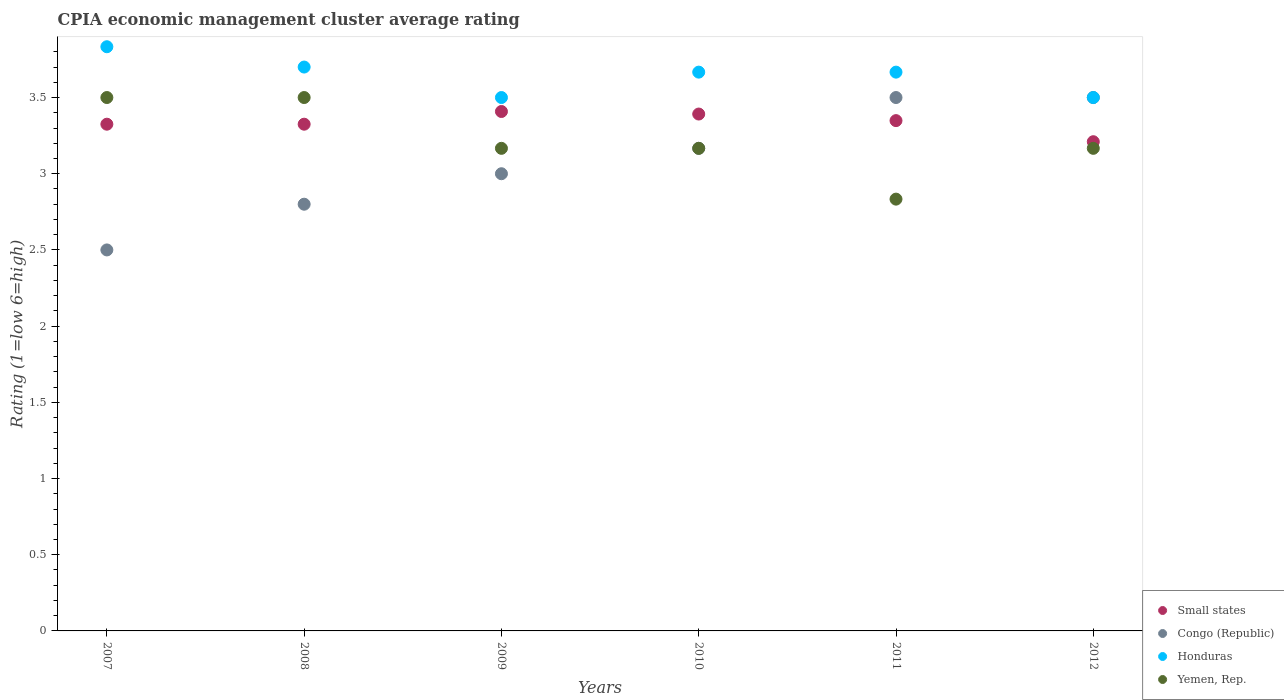How many different coloured dotlines are there?
Provide a short and direct response. 4. What is the CPIA rating in Honduras in 2012?
Your answer should be very brief. 3.5. Across all years, what is the maximum CPIA rating in Honduras?
Offer a terse response. 3.83. Across all years, what is the minimum CPIA rating in Congo (Republic)?
Make the answer very short. 2.5. In which year was the CPIA rating in Small states minimum?
Offer a very short reply. 2012. What is the total CPIA rating in Small states in the graph?
Provide a succinct answer. 20.01. What is the difference between the CPIA rating in Honduras in 2011 and that in 2012?
Keep it short and to the point. 0.17. What is the difference between the CPIA rating in Congo (Republic) in 2009 and the CPIA rating in Honduras in 2007?
Offer a very short reply. -0.83. What is the average CPIA rating in Congo (Republic) per year?
Keep it short and to the point. 3.08. In the year 2008, what is the difference between the CPIA rating in Small states and CPIA rating in Honduras?
Provide a succinct answer. -0.38. In how many years, is the CPIA rating in Congo (Republic) greater than 1.8?
Your response must be concise. 6. What is the ratio of the CPIA rating in Small states in 2007 to that in 2011?
Your answer should be very brief. 0.99. Is the CPIA rating in Small states in 2007 less than that in 2009?
Ensure brevity in your answer.  Yes. Is the difference between the CPIA rating in Small states in 2008 and 2010 greater than the difference between the CPIA rating in Honduras in 2008 and 2010?
Provide a short and direct response. No. What is the difference between the highest and the second highest CPIA rating in Small states?
Your answer should be very brief. 0.02. What is the difference between the highest and the lowest CPIA rating in Yemen, Rep.?
Offer a very short reply. 0.67. Is the sum of the CPIA rating in Honduras in 2007 and 2009 greater than the maximum CPIA rating in Yemen, Rep. across all years?
Offer a very short reply. Yes. Does the CPIA rating in Honduras monotonically increase over the years?
Your response must be concise. No. How many dotlines are there?
Provide a succinct answer. 4. Does the graph contain grids?
Your answer should be very brief. No. Where does the legend appear in the graph?
Keep it short and to the point. Bottom right. What is the title of the graph?
Make the answer very short. CPIA economic management cluster average rating. What is the label or title of the Y-axis?
Your answer should be compact. Rating (1=low 6=high). What is the Rating (1=low 6=high) of Small states in 2007?
Give a very brief answer. 3.33. What is the Rating (1=low 6=high) of Congo (Republic) in 2007?
Your answer should be compact. 2.5. What is the Rating (1=low 6=high) in Honduras in 2007?
Offer a very short reply. 3.83. What is the Rating (1=low 6=high) in Small states in 2008?
Provide a short and direct response. 3.33. What is the Rating (1=low 6=high) of Congo (Republic) in 2008?
Your response must be concise. 2.8. What is the Rating (1=low 6=high) of Small states in 2009?
Provide a succinct answer. 3.41. What is the Rating (1=low 6=high) of Yemen, Rep. in 2009?
Provide a succinct answer. 3.17. What is the Rating (1=low 6=high) in Small states in 2010?
Your answer should be very brief. 3.39. What is the Rating (1=low 6=high) of Congo (Republic) in 2010?
Give a very brief answer. 3.17. What is the Rating (1=low 6=high) of Honduras in 2010?
Ensure brevity in your answer.  3.67. What is the Rating (1=low 6=high) of Yemen, Rep. in 2010?
Offer a very short reply. 3.17. What is the Rating (1=low 6=high) of Small states in 2011?
Your answer should be compact. 3.35. What is the Rating (1=low 6=high) in Honduras in 2011?
Your answer should be compact. 3.67. What is the Rating (1=low 6=high) of Yemen, Rep. in 2011?
Your answer should be compact. 2.83. What is the Rating (1=low 6=high) in Small states in 2012?
Make the answer very short. 3.21. What is the Rating (1=low 6=high) in Congo (Republic) in 2012?
Your answer should be very brief. 3.5. What is the Rating (1=low 6=high) of Yemen, Rep. in 2012?
Offer a terse response. 3.17. Across all years, what is the maximum Rating (1=low 6=high) in Small states?
Your answer should be very brief. 3.41. Across all years, what is the maximum Rating (1=low 6=high) of Honduras?
Offer a very short reply. 3.83. Across all years, what is the minimum Rating (1=low 6=high) of Small states?
Give a very brief answer. 3.21. Across all years, what is the minimum Rating (1=low 6=high) in Honduras?
Your answer should be very brief. 3.5. Across all years, what is the minimum Rating (1=low 6=high) in Yemen, Rep.?
Provide a short and direct response. 2.83. What is the total Rating (1=low 6=high) of Small states in the graph?
Keep it short and to the point. 20.01. What is the total Rating (1=low 6=high) of Congo (Republic) in the graph?
Ensure brevity in your answer.  18.47. What is the total Rating (1=low 6=high) in Honduras in the graph?
Your answer should be compact. 21.87. What is the total Rating (1=low 6=high) of Yemen, Rep. in the graph?
Give a very brief answer. 19.33. What is the difference between the Rating (1=low 6=high) in Small states in 2007 and that in 2008?
Your response must be concise. 0. What is the difference between the Rating (1=low 6=high) in Congo (Republic) in 2007 and that in 2008?
Keep it short and to the point. -0.3. What is the difference between the Rating (1=low 6=high) of Honduras in 2007 and that in 2008?
Provide a short and direct response. 0.13. What is the difference between the Rating (1=low 6=high) of Small states in 2007 and that in 2009?
Your answer should be compact. -0.08. What is the difference between the Rating (1=low 6=high) of Congo (Republic) in 2007 and that in 2009?
Your answer should be compact. -0.5. What is the difference between the Rating (1=low 6=high) of Small states in 2007 and that in 2010?
Provide a short and direct response. -0.07. What is the difference between the Rating (1=low 6=high) of Congo (Republic) in 2007 and that in 2010?
Keep it short and to the point. -0.67. What is the difference between the Rating (1=low 6=high) of Small states in 2007 and that in 2011?
Provide a short and direct response. -0.02. What is the difference between the Rating (1=low 6=high) in Congo (Republic) in 2007 and that in 2011?
Offer a very short reply. -1. What is the difference between the Rating (1=low 6=high) of Honduras in 2007 and that in 2011?
Keep it short and to the point. 0.17. What is the difference between the Rating (1=low 6=high) in Small states in 2007 and that in 2012?
Your response must be concise. 0.11. What is the difference between the Rating (1=low 6=high) of Congo (Republic) in 2007 and that in 2012?
Make the answer very short. -1. What is the difference between the Rating (1=low 6=high) of Honduras in 2007 and that in 2012?
Offer a terse response. 0.33. What is the difference between the Rating (1=low 6=high) of Small states in 2008 and that in 2009?
Ensure brevity in your answer.  -0.08. What is the difference between the Rating (1=low 6=high) of Small states in 2008 and that in 2010?
Keep it short and to the point. -0.07. What is the difference between the Rating (1=low 6=high) in Congo (Republic) in 2008 and that in 2010?
Offer a terse response. -0.37. What is the difference between the Rating (1=low 6=high) in Honduras in 2008 and that in 2010?
Your response must be concise. 0.03. What is the difference between the Rating (1=low 6=high) in Small states in 2008 and that in 2011?
Ensure brevity in your answer.  -0.02. What is the difference between the Rating (1=low 6=high) in Congo (Republic) in 2008 and that in 2011?
Ensure brevity in your answer.  -0.7. What is the difference between the Rating (1=low 6=high) of Honduras in 2008 and that in 2011?
Your response must be concise. 0.03. What is the difference between the Rating (1=low 6=high) in Yemen, Rep. in 2008 and that in 2011?
Give a very brief answer. 0.67. What is the difference between the Rating (1=low 6=high) in Small states in 2008 and that in 2012?
Make the answer very short. 0.11. What is the difference between the Rating (1=low 6=high) in Congo (Republic) in 2008 and that in 2012?
Keep it short and to the point. -0.7. What is the difference between the Rating (1=low 6=high) in Yemen, Rep. in 2008 and that in 2012?
Keep it short and to the point. 0.33. What is the difference between the Rating (1=low 6=high) in Small states in 2009 and that in 2010?
Provide a succinct answer. 0.02. What is the difference between the Rating (1=low 6=high) in Congo (Republic) in 2009 and that in 2010?
Your answer should be compact. -0.17. What is the difference between the Rating (1=low 6=high) in Yemen, Rep. in 2009 and that in 2010?
Offer a very short reply. 0. What is the difference between the Rating (1=low 6=high) in Small states in 2009 and that in 2011?
Make the answer very short. 0.06. What is the difference between the Rating (1=low 6=high) in Small states in 2009 and that in 2012?
Offer a very short reply. 0.2. What is the difference between the Rating (1=low 6=high) in Congo (Republic) in 2009 and that in 2012?
Provide a succinct answer. -0.5. What is the difference between the Rating (1=low 6=high) in Yemen, Rep. in 2009 and that in 2012?
Provide a short and direct response. 0. What is the difference between the Rating (1=low 6=high) of Small states in 2010 and that in 2011?
Provide a short and direct response. 0.04. What is the difference between the Rating (1=low 6=high) of Congo (Republic) in 2010 and that in 2011?
Keep it short and to the point. -0.33. What is the difference between the Rating (1=low 6=high) in Honduras in 2010 and that in 2011?
Ensure brevity in your answer.  0. What is the difference between the Rating (1=low 6=high) of Yemen, Rep. in 2010 and that in 2011?
Keep it short and to the point. 0.33. What is the difference between the Rating (1=low 6=high) in Small states in 2010 and that in 2012?
Offer a terse response. 0.18. What is the difference between the Rating (1=low 6=high) of Congo (Republic) in 2010 and that in 2012?
Ensure brevity in your answer.  -0.33. What is the difference between the Rating (1=low 6=high) in Small states in 2011 and that in 2012?
Offer a very short reply. 0.14. What is the difference between the Rating (1=low 6=high) in Honduras in 2011 and that in 2012?
Give a very brief answer. 0.17. What is the difference between the Rating (1=low 6=high) of Yemen, Rep. in 2011 and that in 2012?
Your answer should be very brief. -0.33. What is the difference between the Rating (1=low 6=high) of Small states in 2007 and the Rating (1=low 6=high) of Congo (Republic) in 2008?
Provide a succinct answer. 0.53. What is the difference between the Rating (1=low 6=high) in Small states in 2007 and the Rating (1=low 6=high) in Honduras in 2008?
Keep it short and to the point. -0.38. What is the difference between the Rating (1=low 6=high) of Small states in 2007 and the Rating (1=low 6=high) of Yemen, Rep. in 2008?
Keep it short and to the point. -0.17. What is the difference between the Rating (1=low 6=high) of Congo (Republic) in 2007 and the Rating (1=low 6=high) of Honduras in 2008?
Your response must be concise. -1.2. What is the difference between the Rating (1=low 6=high) in Congo (Republic) in 2007 and the Rating (1=low 6=high) in Yemen, Rep. in 2008?
Your answer should be very brief. -1. What is the difference between the Rating (1=low 6=high) in Honduras in 2007 and the Rating (1=low 6=high) in Yemen, Rep. in 2008?
Provide a short and direct response. 0.33. What is the difference between the Rating (1=low 6=high) in Small states in 2007 and the Rating (1=low 6=high) in Congo (Republic) in 2009?
Make the answer very short. 0.33. What is the difference between the Rating (1=low 6=high) in Small states in 2007 and the Rating (1=low 6=high) in Honduras in 2009?
Provide a succinct answer. -0.17. What is the difference between the Rating (1=low 6=high) in Small states in 2007 and the Rating (1=low 6=high) in Yemen, Rep. in 2009?
Give a very brief answer. 0.16. What is the difference between the Rating (1=low 6=high) of Honduras in 2007 and the Rating (1=low 6=high) of Yemen, Rep. in 2009?
Give a very brief answer. 0.67. What is the difference between the Rating (1=low 6=high) of Small states in 2007 and the Rating (1=low 6=high) of Congo (Republic) in 2010?
Keep it short and to the point. 0.16. What is the difference between the Rating (1=low 6=high) in Small states in 2007 and the Rating (1=low 6=high) in Honduras in 2010?
Your answer should be compact. -0.34. What is the difference between the Rating (1=low 6=high) in Small states in 2007 and the Rating (1=low 6=high) in Yemen, Rep. in 2010?
Ensure brevity in your answer.  0.16. What is the difference between the Rating (1=low 6=high) in Congo (Republic) in 2007 and the Rating (1=low 6=high) in Honduras in 2010?
Provide a short and direct response. -1.17. What is the difference between the Rating (1=low 6=high) of Honduras in 2007 and the Rating (1=low 6=high) of Yemen, Rep. in 2010?
Keep it short and to the point. 0.67. What is the difference between the Rating (1=low 6=high) of Small states in 2007 and the Rating (1=low 6=high) of Congo (Republic) in 2011?
Provide a succinct answer. -0.17. What is the difference between the Rating (1=low 6=high) in Small states in 2007 and the Rating (1=low 6=high) in Honduras in 2011?
Your response must be concise. -0.34. What is the difference between the Rating (1=low 6=high) in Small states in 2007 and the Rating (1=low 6=high) in Yemen, Rep. in 2011?
Your answer should be very brief. 0.49. What is the difference between the Rating (1=low 6=high) of Congo (Republic) in 2007 and the Rating (1=low 6=high) of Honduras in 2011?
Your response must be concise. -1.17. What is the difference between the Rating (1=low 6=high) in Congo (Republic) in 2007 and the Rating (1=low 6=high) in Yemen, Rep. in 2011?
Ensure brevity in your answer.  -0.33. What is the difference between the Rating (1=low 6=high) in Small states in 2007 and the Rating (1=low 6=high) in Congo (Republic) in 2012?
Make the answer very short. -0.17. What is the difference between the Rating (1=low 6=high) in Small states in 2007 and the Rating (1=low 6=high) in Honduras in 2012?
Your answer should be very brief. -0.17. What is the difference between the Rating (1=low 6=high) in Small states in 2007 and the Rating (1=low 6=high) in Yemen, Rep. in 2012?
Keep it short and to the point. 0.16. What is the difference between the Rating (1=low 6=high) of Congo (Republic) in 2007 and the Rating (1=low 6=high) of Yemen, Rep. in 2012?
Your response must be concise. -0.67. What is the difference between the Rating (1=low 6=high) of Small states in 2008 and the Rating (1=low 6=high) of Congo (Republic) in 2009?
Your response must be concise. 0.33. What is the difference between the Rating (1=low 6=high) in Small states in 2008 and the Rating (1=low 6=high) in Honduras in 2009?
Provide a succinct answer. -0.17. What is the difference between the Rating (1=low 6=high) of Small states in 2008 and the Rating (1=low 6=high) of Yemen, Rep. in 2009?
Offer a terse response. 0.16. What is the difference between the Rating (1=low 6=high) of Congo (Republic) in 2008 and the Rating (1=low 6=high) of Yemen, Rep. in 2009?
Offer a very short reply. -0.37. What is the difference between the Rating (1=low 6=high) in Honduras in 2008 and the Rating (1=low 6=high) in Yemen, Rep. in 2009?
Give a very brief answer. 0.53. What is the difference between the Rating (1=low 6=high) of Small states in 2008 and the Rating (1=low 6=high) of Congo (Republic) in 2010?
Give a very brief answer. 0.16. What is the difference between the Rating (1=low 6=high) in Small states in 2008 and the Rating (1=low 6=high) in Honduras in 2010?
Provide a succinct answer. -0.34. What is the difference between the Rating (1=low 6=high) of Small states in 2008 and the Rating (1=low 6=high) of Yemen, Rep. in 2010?
Offer a very short reply. 0.16. What is the difference between the Rating (1=low 6=high) in Congo (Republic) in 2008 and the Rating (1=low 6=high) in Honduras in 2010?
Give a very brief answer. -0.87. What is the difference between the Rating (1=low 6=high) of Congo (Republic) in 2008 and the Rating (1=low 6=high) of Yemen, Rep. in 2010?
Keep it short and to the point. -0.37. What is the difference between the Rating (1=low 6=high) in Honduras in 2008 and the Rating (1=low 6=high) in Yemen, Rep. in 2010?
Keep it short and to the point. 0.53. What is the difference between the Rating (1=low 6=high) of Small states in 2008 and the Rating (1=low 6=high) of Congo (Republic) in 2011?
Provide a succinct answer. -0.17. What is the difference between the Rating (1=low 6=high) in Small states in 2008 and the Rating (1=low 6=high) in Honduras in 2011?
Your response must be concise. -0.34. What is the difference between the Rating (1=low 6=high) of Small states in 2008 and the Rating (1=low 6=high) of Yemen, Rep. in 2011?
Offer a very short reply. 0.49. What is the difference between the Rating (1=low 6=high) in Congo (Republic) in 2008 and the Rating (1=low 6=high) in Honduras in 2011?
Offer a terse response. -0.87. What is the difference between the Rating (1=low 6=high) in Congo (Republic) in 2008 and the Rating (1=low 6=high) in Yemen, Rep. in 2011?
Give a very brief answer. -0.03. What is the difference between the Rating (1=low 6=high) of Honduras in 2008 and the Rating (1=low 6=high) of Yemen, Rep. in 2011?
Provide a short and direct response. 0.87. What is the difference between the Rating (1=low 6=high) of Small states in 2008 and the Rating (1=low 6=high) of Congo (Republic) in 2012?
Ensure brevity in your answer.  -0.17. What is the difference between the Rating (1=low 6=high) in Small states in 2008 and the Rating (1=low 6=high) in Honduras in 2012?
Ensure brevity in your answer.  -0.17. What is the difference between the Rating (1=low 6=high) in Small states in 2008 and the Rating (1=low 6=high) in Yemen, Rep. in 2012?
Give a very brief answer. 0.16. What is the difference between the Rating (1=low 6=high) of Congo (Republic) in 2008 and the Rating (1=low 6=high) of Yemen, Rep. in 2012?
Ensure brevity in your answer.  -0.37. What is the difference between the Rating (1=low 6=high) of Honduras in 2008 and the Rating (1=low 6=high) of Yemen, Rep. in 2012?
Your answer should be very brief. 0.53. What is the difference between the Rating (1=low 6=high) of Small states in 2009 and the Rating (1=low 6=high) of Congo (Republic) in 2010?
Your response must be concise. 0.24. What is the difference between the Rating (1=low 6=high) of Small states in 2009 and the Rating (1=low 6=high) of Honduras in 2010?
Provide a short and direct response. -0.26. What is the difference between the Rating (1=low 6=high) in Small states in 2009 and the Rating (1=low 6=high) in Yemen, Rep. in 2010?
Your answer should be compact. 0.24. What is the difference between the Rating (1=low 6=high) of Congo (Republic) in 2009 and the Rating (1=low 6=high) of Yemen, Rep. in 2010?
Your response must be concise. -0.17. What is the difference between the Rating (1=low 6=high) in Small states in 2009 and the Rating (1=low 6=high) in Congo (Republic) in 2011?
Ensure brevity in your answer.  -0.09. What is the difference between the Rating (1=low 6=high) of Small states in 2009 and the Rating (1=low 6=high) of Honduras in 2011?
Make the answer very short. -0.26. What is the difference between the Rating (1=low 6=high) of Small states in 2009 and the Rating (1=low 6=high) of Yemen, Rep. in 2011?
Provide a succinct answer. 0.57. What is the difference between the Rating (1=low 6=high) in Small states in 2009 and the Rating (1=low 6=high) in Congo (Republic) in 2012?
Provide a short and direct response. -0.09. What is the difference between the Rating (1=low 6=high) of Small states in 2009 and the Rating (1=low 6=high) of Honduras in 2012?
Provide a succinct answer. -0.09. What is the difference between the Rating (1=low 6=high) of Small states in 2009 and the Rating (1=low 6=high) of Yemen, Rep. in 2012?
Keep it short and to the point. 0.24. What is the difference between the Rating (1=low 6=high) of Congo (Republic) in 2009 and the Rating (1=low 6=high) of Yemen, Rep. in 2012?
Make the answer very short. -0.17. What is the difference between the Rating (1=low 6=high) of Honduras in 2009 and the Rating (1=low 6=high) of Yemen, Rep. in 2012?
Provide a short and direct response. 0.33. What is the difference between the Rating (1=low 6=high) of Small states in 2010 and the Rating (1=low 6=high) of Congo (Republic) in 2011?
Your response must be concise. -0.11. What is the difference between the Rating (1=low 6=high) in Small states in 2010 and the Rating (1=low 6=high) in Honduras in 2011?
Your response must be concise. -0.28. What is the difference between the Rating (1=low 6=high) of Small states in 2010 and the Rating (1=low 6=high) of Yemen, Rep. in 2011?
Your answer should be very brief. 0.56. What is the difference between the Rating (1=low 6=high) in Congo (Republic) in 2010 and the Rating (1=low 6=high) in Yemen, Rep. in 2011?
Provide a short and direct response. 0.33. What is the difference between the Rating (1=low 6=high) in Honduras in 2010 and the Rating (1=low 6=high) in Yemen, Rep. in 2011?
Make the answer very short. 0.83. What is the difference between the Rating (1=low 6=high) in Small states in 2010 and the Rating (1=low 6=high) in Congo (Republic) in 2012?
Your answer should be compact. -0.11. What is the difference between the Rating (1=low 6=high) of Small states in 2010 and the Rating (1=low 6=high) of Honduras in 2012?
Keep it short and to the point. -0.11. What is the difference between the Rating (1=low 6=high) in Small states in 2010 and the Rating (1=low 6=high) in Yemen, Rep. in 2012?
Your answer should be compact. 0.23. What is the difference between the Rating (1=low 6=high) in Congo (Republic) in 2010 and the Rating (1=low 6=high) in Honduras in 2012?
Give a very brief answer. -0.33. What is the difference between the Rating (1=low 6=high) of Congo (Republic) in 2010 and the Rating (1=low 6=high) of Yemen, Rep. in 2012?
Ensure brevity in your answer.  0. What is the difference between the Rating (1=low 6=high) in Honduras in 2010 and the Rating (1=low 6=high) in Yemen, Rep. in 2012?
Your answer should be compact. 0.5. What is the difference between the Rating (1=low 6=high) of Small states in 2011 and the Rating (1=low 6=high) of Congo (Republic) in 2012?
Ensure brevity in your answer.  -0.15. What is the difference between the Rating (1=low 6=high) of Small states in 2011 and the Rating (1=low 6=high) of Honduras in 2012?
Your answer should be compact. -0.15. What is the difference between the Rating (1=low 6=high) in Small states in 2011 and the Rating (1=low 6=high) in Yemen, Rep. in 2012?
Make the answer very short. 0.18. What is the average Rating (1=low 6=high) of Small states per year?
Offer a very short reply. 3.33. What is the average Rating (1=low 6=high) in Congo (Republic) per year?
Offer a very short reply. 3.08. What is the average Rating (1=low 6=high) in Honduras per year?
Your answer should be compact. 3.64. What is the average Rating (1=low 6=high) in Yemen, Rep. per year?
Offer a very short reply. 3.22. In the year 2007, what is the difference between the Rating (1=low 6=high) of Small states and Rating (1=low 6=high) of Congo (Republic)?
Ensure brevity in your answer.  0.82. In the year 2007, what is the difference between the Rating (1=low 6=high) of Small states and Rating (1=low 6=high) of Honduras?
Offer a terse response. -0.51. In the year 2007, what is the difference between the Rating (1=low 6=high) in Small states and Rating (1=low 6=high) in Yemen, Rep.?
Offer a very short reply. -0.17. In the year 2007, what is the difference between the Rating (1=low 6=high) in Congo (Republic) and Rating (1=low 6=high) in Honduras?
Keep it short and to the point. -1.33. In the year 2007, what is the difference between the Rating (1=low 6=high) in Honduras and Rating (1=low 6=high) in Yemen, Rep.?
Keep it short and to the point. 0.33. In the year 2008, what is the difference between the Rating (1=low 6=high) of Small states and Rating (1=low 6=high) of Congo (Republic)?
Your answer should be compact. 0.53. In the year 2008, what is the difference between the Rating (1=low 6=high) in Small states and Rating (1=low 6=high) in Honduras?
Offer a terse response. -0.38. In the year 2008, what is the difference between the Rating (1=low 6=high) in Small states and Rating (1=low 6=high) in Yemen, Rep.?
Your response must be concise. -0.17. In the year 2008, what is the difference between the Rating (1=low 6=high) of Congo (Republic) and Rating (1=low 6=high) of Yemen, Rep.?
Your answer should be very brief. -0.7. In the year 2009, what is the difference between the Rating (1=low 6=high) of Small states and Rating (1=low 6=high) of Congo (Republic)?
Your response must be concise. 0.41. In the year 2009, what is the difference between the Rating (1=low 6=high) of Small states and Rating (1=low 6=high) of Honduras?
Make the answer very short. -0.09. In the year 2009, what is the difference between the Rating (1=low 6=high) in Small states and Rating (1=low 6=high) in Yemen, Rep.?
Your answer should be very brief. 0.24. In the year 2009, what is the difference between the Rating (1=low 6=high) of Congo (Republic) and Rating (1=low 6=high) of Honduras?
Offer a very short reply. -0.5. In the year 2009, what is the difference between the Rating (1=low 6=high) of Congo (Republic) and Rating (1=low 6=high) of Yemen, Rep.?
Make the answer very short. -0.17. In the year 2010, what is the difference between the Rating (1=low 6=high) in Small states and Rating (1=low 6=high) in Congo (Republic)?
Your response must be concise. 0.23. In the year 2010, what is the difference between the Rating (1=low 6=high) of Small states and Rating (1=low 6=high) of Honduras?
Your answer should be compact. -0.28. In the year 2010, what is the difference between the Rating (1=low 6=high) of Small states and Rating (1=low 6=high) of Yemen, Rep.?
Offer a very short reply. 0.23. In the year 2010, what is the difference between the Rating (1=low 6=high) in Congo (Republic) and Rating (1=low 6=high) in Honduras?
Give a very brief answer. -0.5. In the year 2010, what is the difference between the Rating (1=low 6=high) in Honduras and Rating (1=low 6=high) in Yemen, Rep.?
Your response must be concise. 0.5. In the year 2011, what is the difference between the Rating (1=low 6=high) in Small states and Rating (1=low 6=high) in Congo (Republic)?
Offer a terse response. -0.15. In the year 2011, what is the difference between the Rating (1=low 6=high) of Small states and Rating (1=low 6=high) of Honduras?
Ensure brevity in your answer.  -0.32. In the year 2011, what is the difference between the Rating (1=low 6=high) in Small states and Rating (1=low 6=high) in Yemen, Rep.?
Provide a succinct answer. 0.52. In the year 2011, what is the difference between the Rating (1=low 6=high) in Congo (Republic) and Rating (1=low 6=high) in Yemen, Rep.?
Provide a short and direct response. 0.67. In the year 2011, what is the difference between the Rating (1=low 6=high) of Honduras and Rating (1=low 6=high) of Yemen, Rep.?
Provide a short and direct response. 0.83. In the year 2012, what is the difference between the Rating (1=low 6=high) in Small states and Rating (1=low 6=high) in Congo (Republic)?
Keep it short and to the point. -0.29. In the year 2012, what is the difference between the Rating (1=low 6=high) of Small states and Rating (1=low 6=high) of Honduras?
Offer a very short reply. -0.29. In the year 2012, what is the difference between the Rating (1=low 6=high) of Small states and Rating (1=low 6=high) of Yemen, Rep.?
Ensure brevity in your answer.  0.04. In the year 2012, what is the difference between the Rating (1=low 6=high) of Congo (Republic) and Rating (1=low 6=high) of Honduras?
Your answer should be very brief. 0. In the year 2012, what is the difference between the Rating (1=low 6=high) in Congo (Republic) and Rating (1=low 6=high) in Yemen, Rep.?
Ensure brevity in your answer.  0.33. What is the ratio of the Rating (1=low 6=high) in Congo (Republic) in 2007 to that in 2008?
Make the answer very short. 0.89. What is the ratio of the Rating (1=low 6=high) of Honduras in 2007 to that in 2008?
Your response must be concise. 1.04. What is the ratio of the Rating (1=low 6=high) of Yemen, Rep. in 2007 to that in 2008?
Your response must be concise. 1. What is the ratio of the Rating (1=low 6=high) in Small states in 2007 to that in 2009?
Provide a short and direct response. 0.98. What is the ratio of the Rating (1=low 6=high) of Congo (Republic) in 2007 to that in 2009?
Your response must be concise. 0.83. What is the ratio of the Rating (1=low 6=high) in Honduras in 2007 to that in 2009?
Make the answer very short. 1.1. What is the ratio of the Rating (1=low 6=high) in Yemen, Rep. in 2007 to that in 2009?
Give a very brief answer. 1.11. What is the ratio of the Rating (1=low 6=high) of Small states in 2007 to that in 2010?
Your response must be concise. 0.98. What is the ratio of the Rating (1=low 6=high) in Congo (Republic) in 2007 to that in 2010?
Your answer should be very brief. 0.79. What is the ratio of the Rating (1=low 6=high) in Honduras in 2007 to that in 2010?
Give a very brief answer. 1.05. What is the ratio of the Rating (1=low 6=high) of Yemen, Rep. in 2007 to that in 2010?
Make the answer very short. 1.11. What is the ratio of the Rating (1=low 6=high) in Small states in 2007 to that in 2011?
Your answer should be compact. 0.99. What is the ratio of the Rating (1=low 6=high) of Congo (Republic) in 2007 to that in 2011?
Your answer should be compact. 0.71. What is the ratio of the Rating (1=low 6=high) of Honduras in 2007 to that in 2011?
Provide a succinct answer. 1.05. What is the ratio of the Rating (1=low 6=high) in Yemen, Rep. in 2007 to that in 2011?
Offer a very short reply. 1.24. What is the ratio of the Rating (1=low 6=high) of Small states in 2007 to that in 2012?
Ensure brevity in your answer.  1.04. What is the ratio of the Rating (1=low 6=high) in Congo (Republic) in 2007 to that in 2012?
Your answer should be very brief. 0.71. What is the ratio of the Rating (1=low 6=high) in Honduras in 2007 to that in 2012?
Offer a very short reply. 1.1. What is the ratio of the Rating (1=low 6=high) of Yemen, Rep. in 2007 to that in 2012?
Keep it short and to the point. 1.11. What is the ratio of the Rating (1=low 6=high) of Small states in 2008 to that in 2009?
Offer a terse response. 0.98. What is the ratio of the Rating (1=low 6=high) in Honduras in 2008 to that in 2009?
Ensure brevity in your answer.  1.06. What is the ratio of the Rating (1=low 6=high) of Yemen, Rep. in 2008 to that in 2009?
Offer a terse response. 1.11. What is the ratio of the Rating (1=low 6=high) in Small states in 2008 to that in 2010?
Offer a terse response. 0.98. What is the ratio of the Rating (1=low 6=high) in Congo (Republic) in 2008 to that in 2010?
Your answer should be very brief. 0.88. What is the ratio of the Rating (1=low 6=high) in Honduras in 2008 to that in 2010?
Your answer should be compact. 1.01. What is the ratio of the Rating (1=low 6=high) in Yemen, Rep. in 2008 to that in 2010?
Ensure brevity in your answer.  1.11. What is the ratio of the Rating (1=low 6=high) in Congo (Republic) in 2008 to that in 2011?
Offer a very short reply. 0.8. What is the ratio of the Rating (1=low 6=high) of Honduras in 2008 to that in 2011?
Your response must be concise. 1.01. What is the ratio of the Rating (1=low 6=high) in Yemen, Rep. in 2008 to that in 2011?
Your answer should be compact. 1.24. What is the ratio of the Rating (1=low 6=high) of Small states in 2008 to that in 2012?
Offer a terse response. 1.04. What is the ratio of the Rating (1=low 6=high) in Honduras in 2008 to that in 2012?
Give a very brief answer. 1.06. What is the ratio of the Rating (1=low 6=high) of Yemen, Rep. in 2008 to that in 2012?
Provide a succinct answer. 1.11. What is the ratio of the Rating (1=low 6=high) of Honduras in 2009 to that in 2010?
Offer a very short reply. 0.95. What is the ratio of the Rating (1=low 6=high) in Small states in 2009 to that in 2011?
Provide a succinct answer. 1.02. What is the ratio of the Rating (1=low 6=high) of Honduras in 2009 to that in 2011?
Your answer should be compact. 0.95. What is the ratio of the Rating (1=low 6=high) in Yemen, Rep. in 2009 to that in 2011?
Ensure brevity in your answer.  1.12. What is the ratio of the Rating (1=low 6=high) of Small states in 2009 to that in 2012?
Provide a succinct answer. 1.06. What is the ratio of the Rating (1=low 6=high) in Congo (Republic) in 2009 to that in 2012?
Your answer should be compact. 0.86. What is the ratio of the Rating (1=low 6=high) of Honduras in 2009 to that in 2012?
Provide a short and direct response. 1. What is the ratio of the Rating (1=low 6=high) of Small states in 2010 to that in 2011?
Your response must be concise. 1.01. What is the ratio of the Rating (1=low 6=high) of Congo (Republic) in 2010 to that in 2011?
Ensure brevity in your answer.  0.9. What is the ratio of the Rating (1=low 6=high) of Yemen, Rep. in 2010 to that in 2011?
Ensure brevity in your answer.  1.12. What is the ratio of the Rating (1=low 6=high) of Small states in 2010 to that in 2012?
Provide a succinct answer. 1.06. What is the ratio of the Rating (1=low 6=high) of Congo (Republic) in 2010 to that in 2012?
Provide a short and direct response. 0.9. What is the ratio of the Rating (1=low 6=high) of Honduras in 2010 to that in 2012?
Your answer should be very brief. 1.05. What is the ratio of the Rating (1=low 6=high) of Yemen, Rep. in 2010 to that in 2012?
Offer a very short reply. 1. What is the ratio of the Rating (1=low 6=high) in Small states in 2011 to that in 2012?
Your answer should be compact. 1.04. What is the ratio of the Rating (1=low 6=high) of Congo (Republic) in 2011 to that in 2012?
Provide a succinct answer. 1. What is the ratio of the Rating (1=low 6=high) in Honduras in 2011 to that in 2012?
Make the answer very short. 1.05. What is the ratio of the Rating (1=low 6=high) of Yemen, Rep. in 2011 to that in 2012?
Your answer should be very brief. 0.89. What is the difference between the highest and the second highest Rating (1=low 6=high) of Small states?
Give a very brief answer. 0.02. What is the difference between the highest and the second highest Rating (1=low 6=high) of Honduras?
Make the answer very short. 0.13. What is the difference between the highest and the second highest Rating (1=low 6=high) of Yemen, Rep.?
Provide a short and direct response. 0. What is the difference between the highest and the lowest Rating (1=low 6=high) in Small states?
Your answer should be very brief. 0.2. What is the difference between the highest and the lowest Rating (1=low 6=high) in Honduras?
Give a very brief answer. 0.33. 